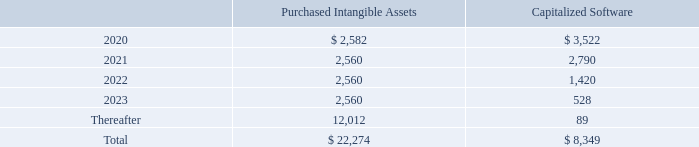The Company recorded amortization expense of $4.8 million, $1.5 million and $0.1 million for the years ended March 31, 2019, 2018 and 2017, respectively. Amortization relating to developed technology and capitalized software was recorded within cost of revenue and amortization of customer relationships and trade names was recorded within sales and marketing expenses.
Future estimated amortization expense of intangible assets as of March 31, 2019 is as follows:
How much did the Company recorded amortization expense for the year ended March 31, 2019? $4.8 million. How much did the Company recorded amortization expense for the year ended March 31, 2018? $1.5 million. How much did the Company recorded amortization expense for the year ended March 31, 2017? $0.1 million. What is the change in Capitalized Software from 2020 to 2021? 2,790-3,522
Answer: -732. What is the change in Capitalized Software from 2021 to 2022? 1,420-2,790
Answer: -1370. What is the change in Capitalized Software from 2022 to 2023? 528-1,420
Answer: -892. 